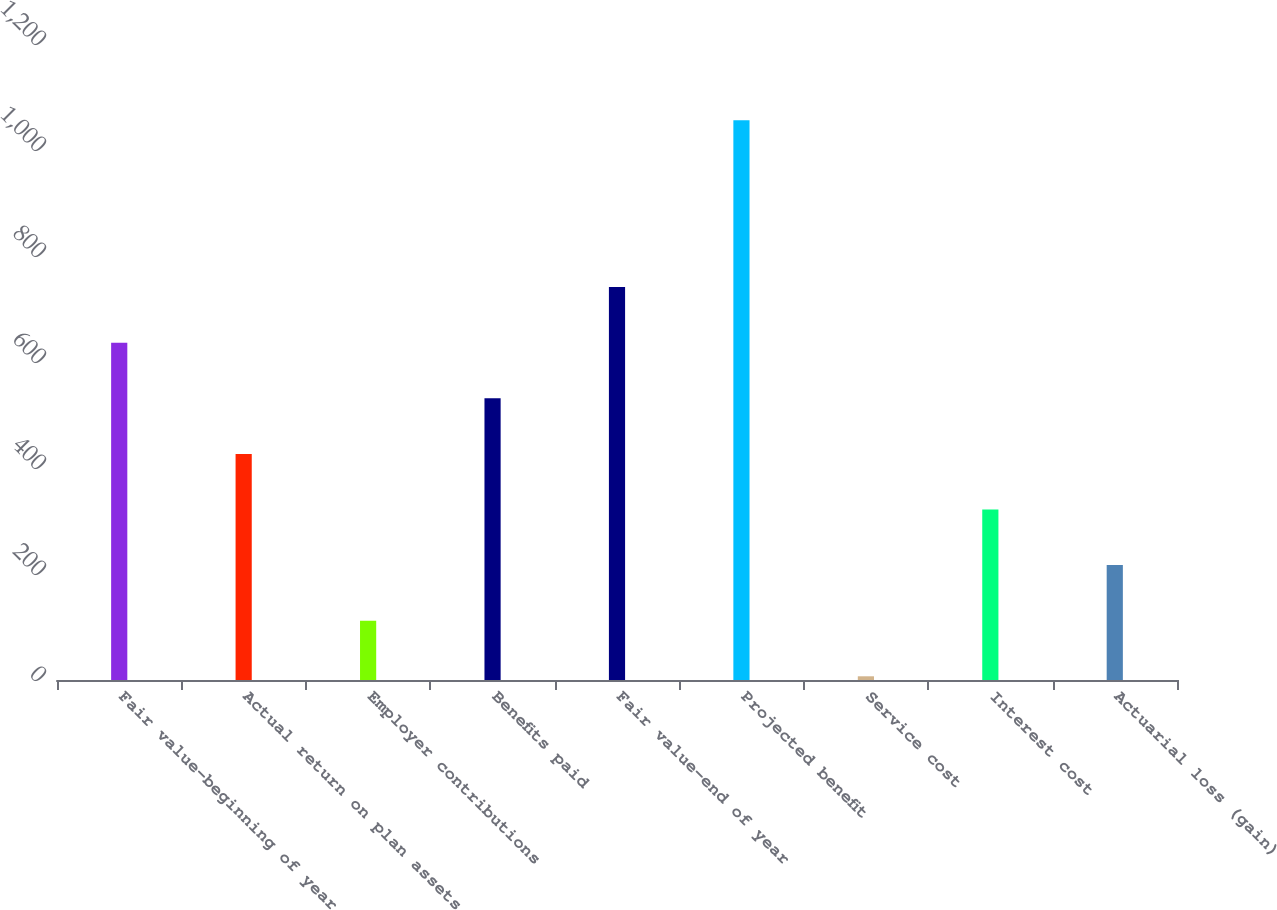<chart> <loc_0><loc_0><loc_500><loc_500><bar_chart><fcel>Fair value-beginning of year<fcel>Actual return on plan assets<fcel>Employer contributions<fcel>Benefits paid<fcel>Fair value-end of year<fcel>Projected benefit<fcel>Service cost<fcel>Interest cost<fcel>Actuarial loss (gain)<nl><fcel>636.4<fcel>426.6<fcel>111.9<fcel>531.5<fcel>741.3<fcel>1056<fcel>7<fcel>321.7<fcel>216.8<nl></chart> 